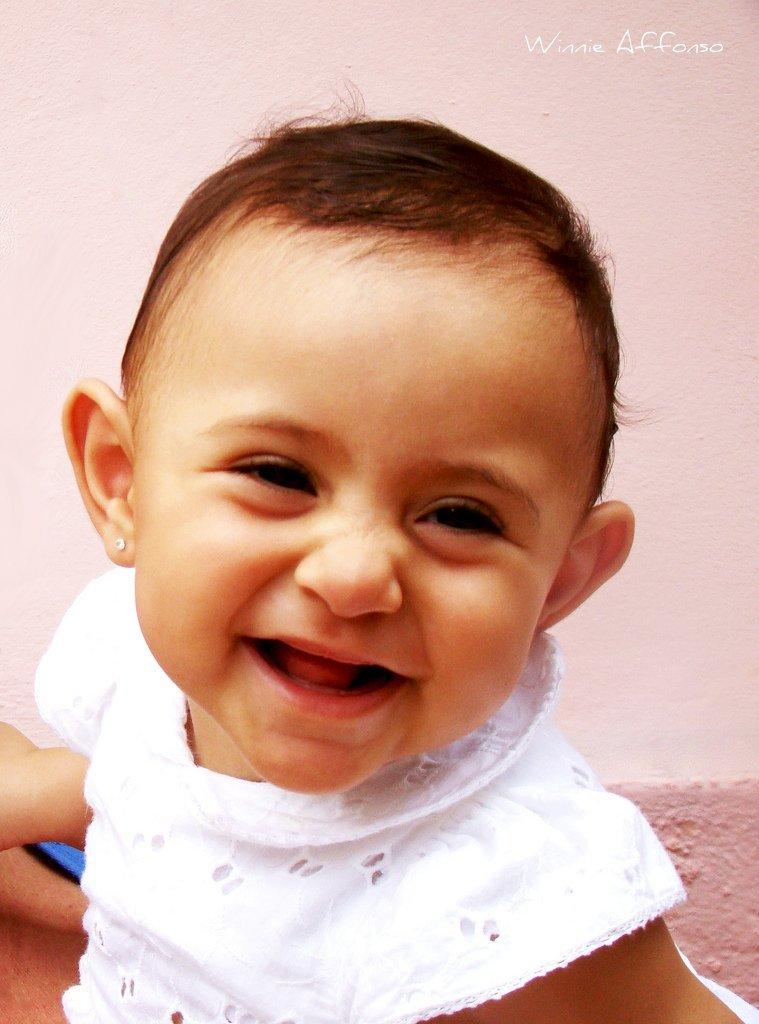What is the main subject of the image? The main subject of the image is a kid. What is the kid doing in the image? The kid is smiling in the image. What can be seen in the background of the image? There is a wall in the background of the image. Where is the text located in the image? The text is visible in the top right side of the image. What type of gun can be seen in the image? There is no gun present in the image; it features a smiling kid. 